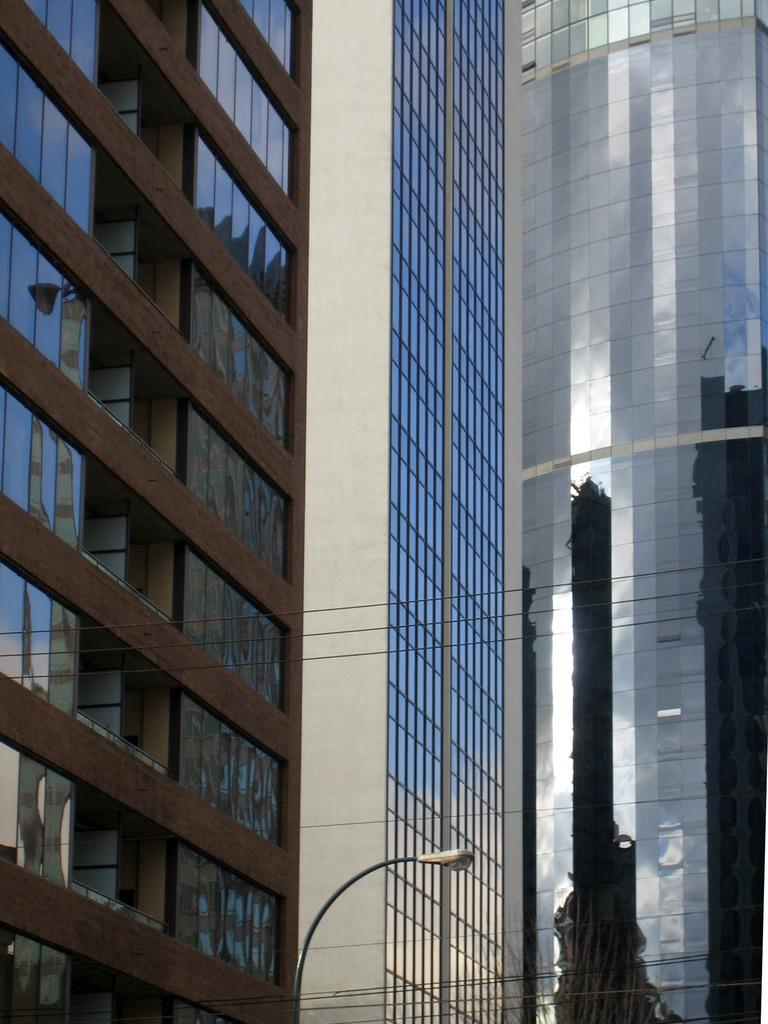What type of structures can be seen in the image? There are buildings in the image. What objects are present that might be used for drinking? There are glasses in the image. What is the source of light in the image? There is a light attached to a pole in the image. What advice does the grandmother give to the owner in the image? There is no grandmother or owner present in the image, so it is not possible to answer that question. 